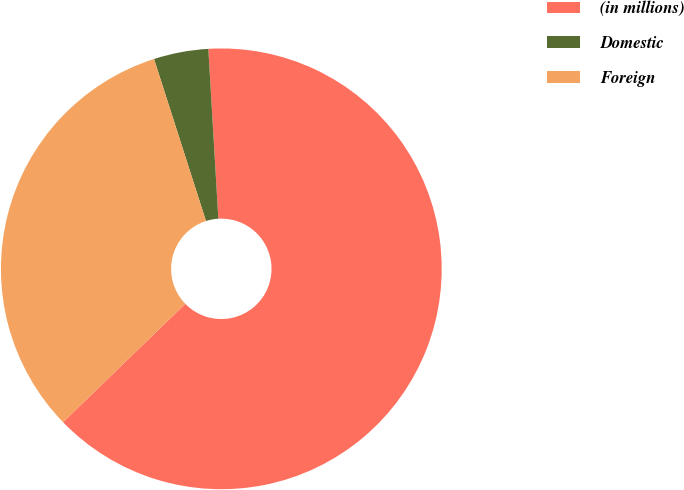<chart> <loc_0><loc_0><loc_500><loc_500><pie_chart><fcel>(in millions)<fcel>Domestic<fcel>Foreign<nl><fcel>63.69%<fcel>4.0%<fcel>32.31%<nl></chart> 